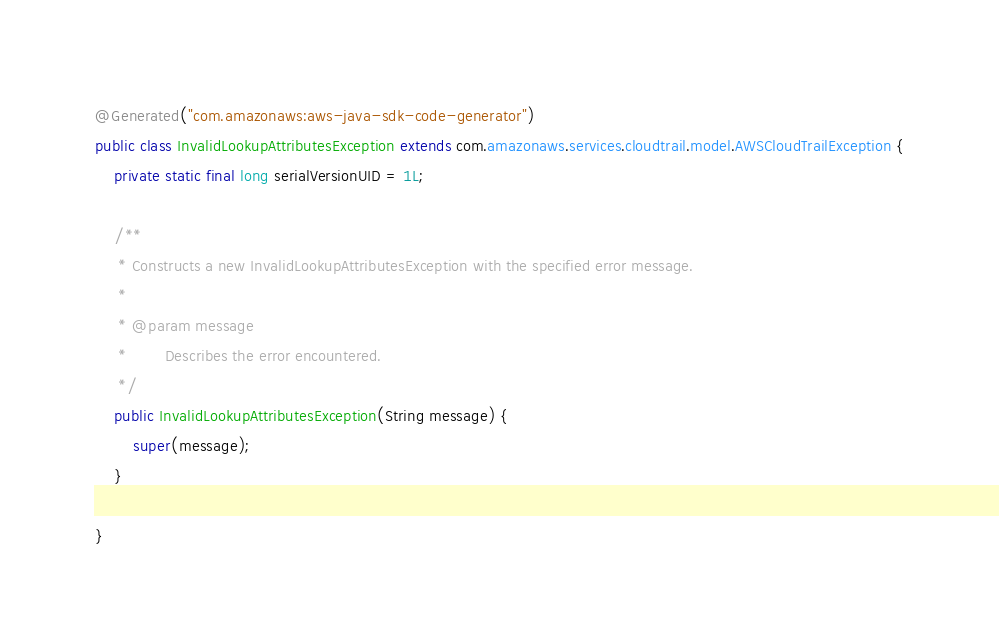<code> <loc_0><loc_0><loc_500><loc_500><_Java_>@Generated("com.amazonaws:aws-java-sdk-code-generator")
public class InvalidLookupAttributesException extends com.amazonaws.services.cloudtrail.model.AWSCloudTrailException {
    private static final long serialVersionUID = 1L;

    /**
     * Constructs a new InvalidLookupAttributesException with the specified error message.
     *
     * @param message
     *        Describes the error encountered.
     */
    public InvalidLookupAttributesException(String message) {
        super(message);
    }

}
</code> 